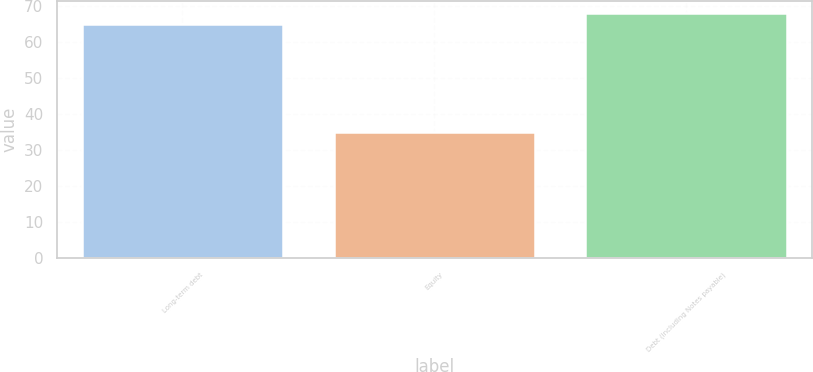<chart> <loc_0><loc_0><loc_500><loc_500><bar_chart><fcel>Long-term debt<fcel>Equity<fcel>Debt (including Notes payable)<nl><fcel>65<fcel>35<fcel>68<nl></chart> 